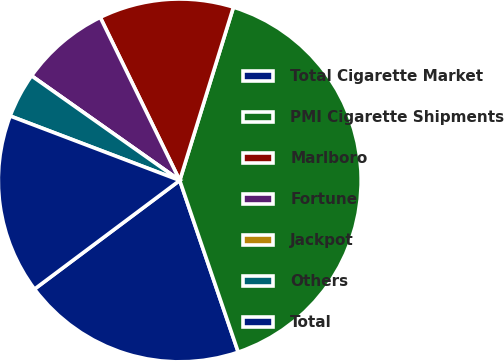<chart> <loc_0><loc_0><loc_500><loc_500><pie_chart><fcel>Total Cigarette Market<fcel>PMI Cigarette Shipments<fcel>Marlboro<fcel>Fortune<fcel>Jackpot<fcel>Others<fcel>Total<nl><fcel>20.0%<fcel>39.99%<fcel>12.0%<fcel>8.0%<fcel>0.0%<fcel>4.0%<fcel>16.0%<nl></chart> 